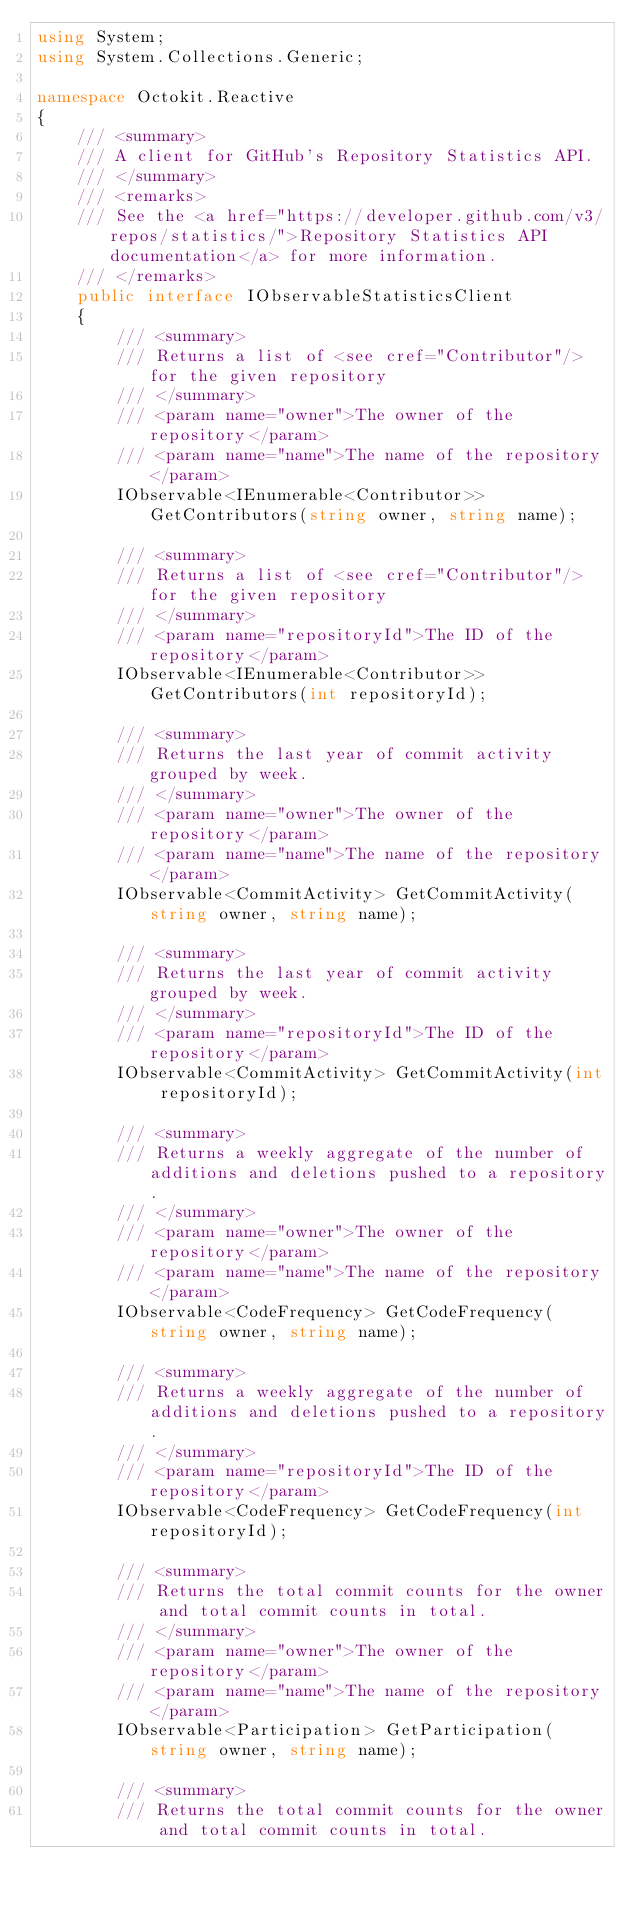<code> <loc_0><loc_0><loc_500><loc_500><_C#_>using System;
using System.Collections.Generic;

namespace Octokit.Reactive
{
    /// <summary>
    /// A client for GitHub's Repository Statistics API.
    /// </summary>
    /// <remarks>
    /// See the <a href="https://developer.github.com/v3/repos/statistics/">Repository Statistics API documentation</a> for more information.
    /// </remarks>
    public interface IObservableStatisticsClient
    {
        /// <summary>
        /// Returns a list of <see cref="Contributor"/> for the given repository
        /// </summary>
        /// <param name="owner">The owner of the repository</param>
        /// <param name="name">The name of the repository</param>
        IObservable<IEnumerable<Contributor>> GetContributors(string owner, string name);

        /// <summary>
        /// Returns a list of <see cref="Contributor"/> for the given repository
        /// </summary>
        /// <param name="repositoryId">The ID of the repository</param>
        IObservable<IEnumerable<Contributor>> GetContributors(int repositoryId);

        /// <summary>
        /// Returns the last year of commit activity grouped by week.
        /// </summary>
        /// <param name="owner">The owner of the repository</param>
        /// <param name="name">The name of the repository</param>
        IObservable<CommitActivity> GetCommitActivity(string owner, string name);

        /// <summary>
        /// Returns the last year of commit activity grouped by week.
        /// </summary>
        /// <param name="repositoryId">The ID of the repository</param>
        IObservable<CommitActivity> GetCommitActivity(int repositoryId);

        /// <summary>
        /// Returns a weekly aggregate of the number of additions and deletions pushed to a repository.
        /// </summary>
        /// <param name="owner">The owner of the repository</param>
        /// <param name="name">The name of the repository</param>
        IObservable<CodeFrequency> GetCodeFrequency(string owner, string name);

        /// <summary>
        /// Returns a weekly aggregate of the number of additions and deletions pushed to a repository.
        /// </summary>
        /// <param name="repositoryId">The ID of the repository</param>
        IObservable<CodeFrequency> GetCodeFrequency(int repositoryId);

        /// <summary>
        /// Returns the total commit counts for the owner and total commit counts in total. 
        /// </summary>
        /// <param name="owner">The owner of the repository</param>
        /// <param name="name">The name of the repository</param>
        IObservable<Participation> GetParticipation(string owner, string name);

        /// <summary>
        /// Returns the total commit counts for the owner and total commit counts in total. </code> 